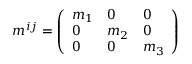Convert formula to latex. <formula><loc_0><loc_0><loc_500><loc_500>m ^ { i j } = \left ( \begin{array} { l l l } { m _ { 1 } } & { 0 } & { 0 } \\ { 0 } & { m _ { 2 } } & { 0 } \\ { 0 } & { 0 } & { m _ { 3 } } \end{array} \right )</formula> 